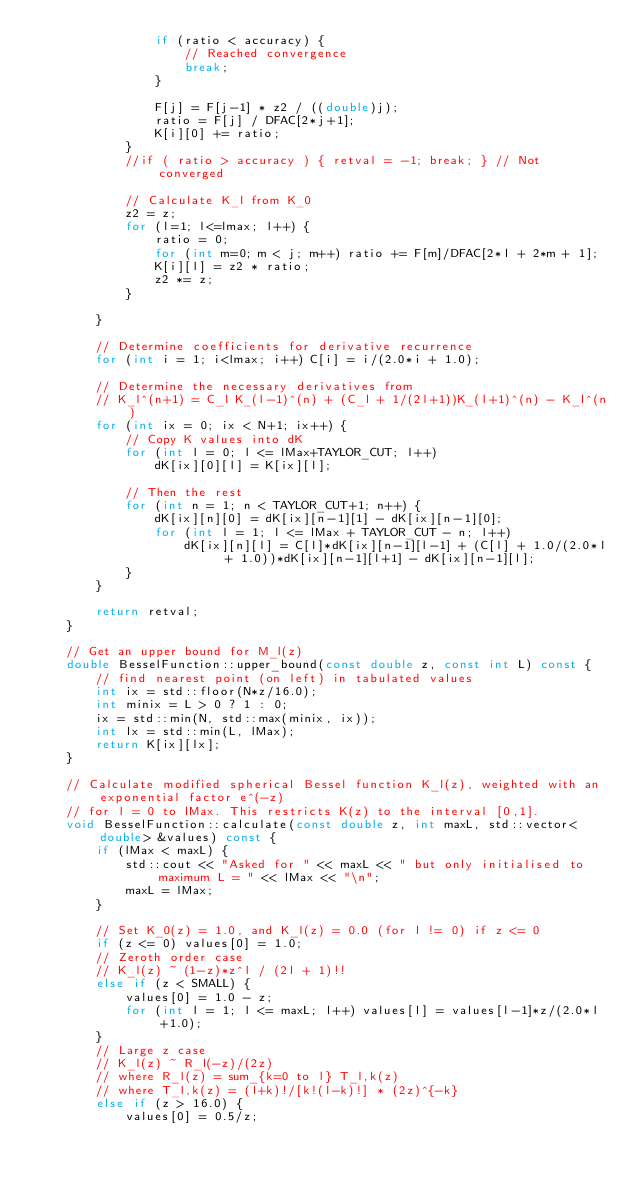<code> <loc_0><loc_0><loc_500><loc_500><_C++_>				if (ratio < accuracy) {
					// Reached convergence
					break;
				} 
			
				F[j] = F[j-1] * z2 / ((double)j);
				ratio = F[j] / DFAC[2*j+1];
				K[i][0] += ratio;
			}
			//if ( ratio > accuracy ) { retval = -1; break; } // Not converged

			// Calculate K_l from K_0
			z2 = z;
			for (l=1; l<=lmax; l++) {
				ratio = 0;
				for (int m=0; m < j; m++) ratio += F[m]/DFAC[2*l + 2*m + 1]; 
				K[i][l] = z2 * ratio;
				z2 *= z; 
			}
	
		}
	
		// Determine coefficients for derivative recurrence
		for (int i = 1; i<lmax; i++) C[i] = i/(2.0*i + 1.0);
		
		// Determine the necessary derivatives from
		// K_l^(n+1) = C_l K_(l-1)^(n) + (C_l + 1/(2l+1))K_(l+1)^(n) - K_l^(n)
		for (int ix = 0; ix < N+1; ix++) {
			// Copy K values into dK
			for (int l = 0; l <= lMax+TAYLOR_CUT; l++)
				dK[ix][0][l] = K[ix][l];
	    	
			// Then the rest
			for (int n = 1; n < TAYLOR_CUT+1; n++) { 
				dK[ix][n][0] = dK[ix][n-1][1] - dK[ix][n-1][0];
				for (int l = 1; l <= lMax + TAYLOR_CUT - n; l++) 
					dK[ix][n][l] = C[l]*dK[ix][n-1][l-1] + (C[l] + 1.0/(2.0*l + 1.0))*dK[ix][n-1][l+1] - dK[ix][n-1][l];
			}
		}
	
		return retval;
	}	

	// Get an upper bound for M_l(z)
	double BesselFunction::upper_bound(const double z, const int L) const {
		// find nearest point (on left) in tabulated values
		int ix = std::floor(N*z/16.0);
		int minix = L > 0 ? 1 : 0;
		ix = std::min(N, std::max(minix, ix));
		int lx = std::min(L, lMax);
		return K[ix][lx];
	}

	// Calculate modified spherical Bessel function K_l(z), weighted with an exponential factor e^(-z)
	// for l = 0 to lMax. This restricts K(z) to the interval [0,1].
	void BesselFunction::calculate(const double z, int maxL, std::vector<double> &values) const {
		if (lMax < maxL) {
			std::cout << "Asked for " << maxL << " but only initialised to maximum L = " << lMax << "\n";
			maxL = lMax;
		}
	
		// Set K_0(z) = 1.0, and K_l(z) = 0.0 (for l != 0) if z <= 0
		if (z <= 0) values[0] = 1.0;
		// Zeroth order case
		// K_l(z) ~ (1-z)*z^l / (2l + 1)!!
		else if (z < SMALL) { 
			values[0] = 1.0 - z;
			for (int l = 1; l <= maxL; l++) values[l] = values[l-1]*z/(2.0*l+1.0);
		} 
		// Large z case
		// K_l(z) ~ R_l(-z)/(2z)
		// where R_l(z) = sum_{k=0 to l} T_l,k(z)
		// where T_l,k(z) = (l+k)!/[k!(l-k)!] * (2z)^{-k}
		else if (z > 16.0) {
			values[0] = 0.5/z;</code> 